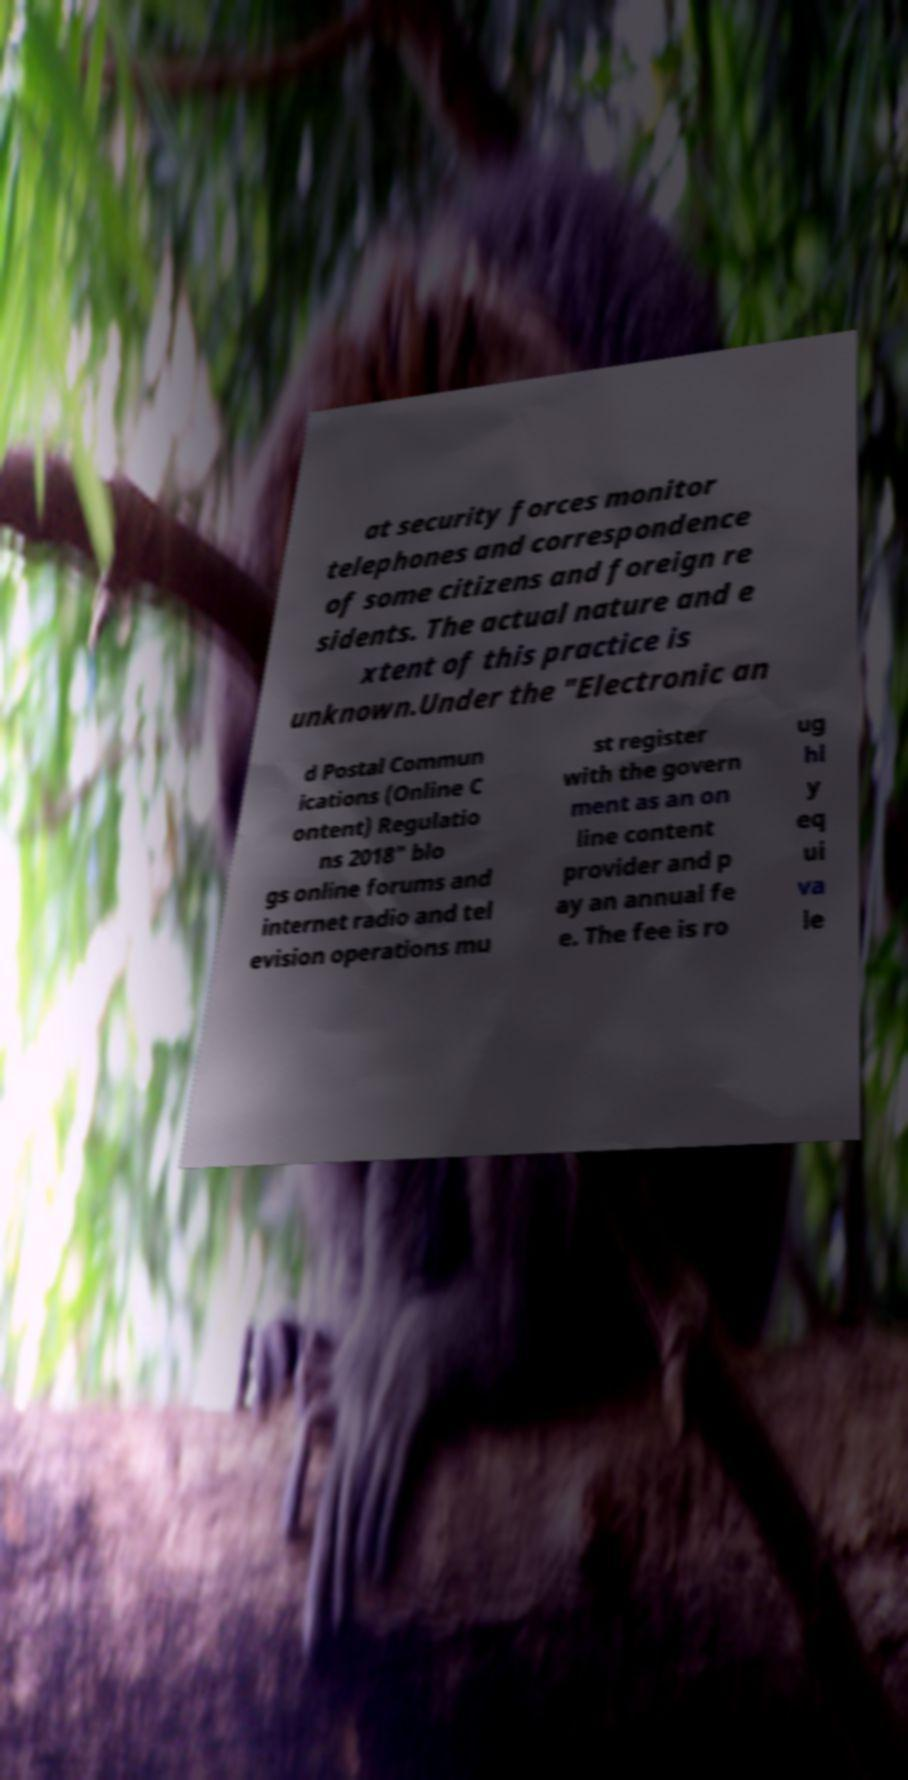Can you read and provide the text displayed in the image?This photo seems to have some interesting text. Can you extract and type it out for me? at security forces monitor telephones and correspondence of some citizens and foreign re sidents. The actual nature and e xtent of this practice is unknown.Under the "Electronic an d Postal Commun ications (Online C ontent) Regulatio ns 2018" blo gs online forums and internet radio and tel evision operations mu st register with the govern ment as an on line content provider and p ay an annual fe e. The fee is ro ug hl y eq ui va le 